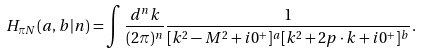Convert formula to latex. <formula><loc_0><loc_0><loc_500><loc_500>H _ { { \pi } N } ( a , b | n ) = \int \frac { d ^ { n } k } { ( 2 \pi ) ^ { n } } \frac { 1 } { [ k ^ { 2 } - M ^ { 2 } + i 0 ^ { + } ] ^ { a } [ k ^ { 2 } + 2 p \cdot k + i 0 ^ { + } ] ^ { b } } .</formula> 